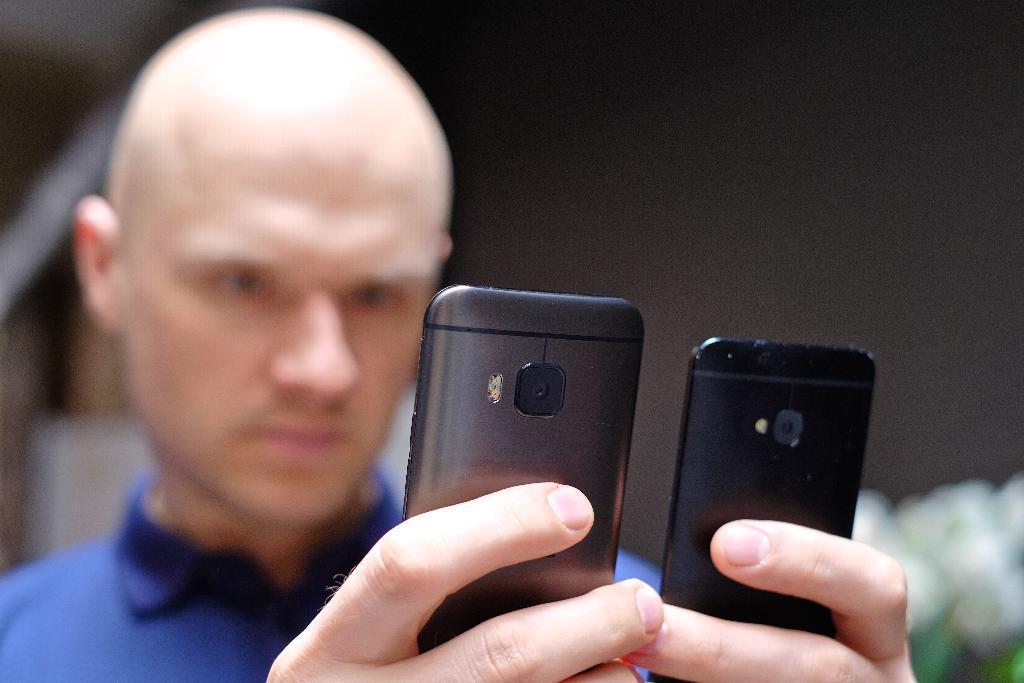Describe this image in one or two sentences. In this image, There is a man who is holding the mobile phones which are in black color, He is wearing a blue color shirt. 